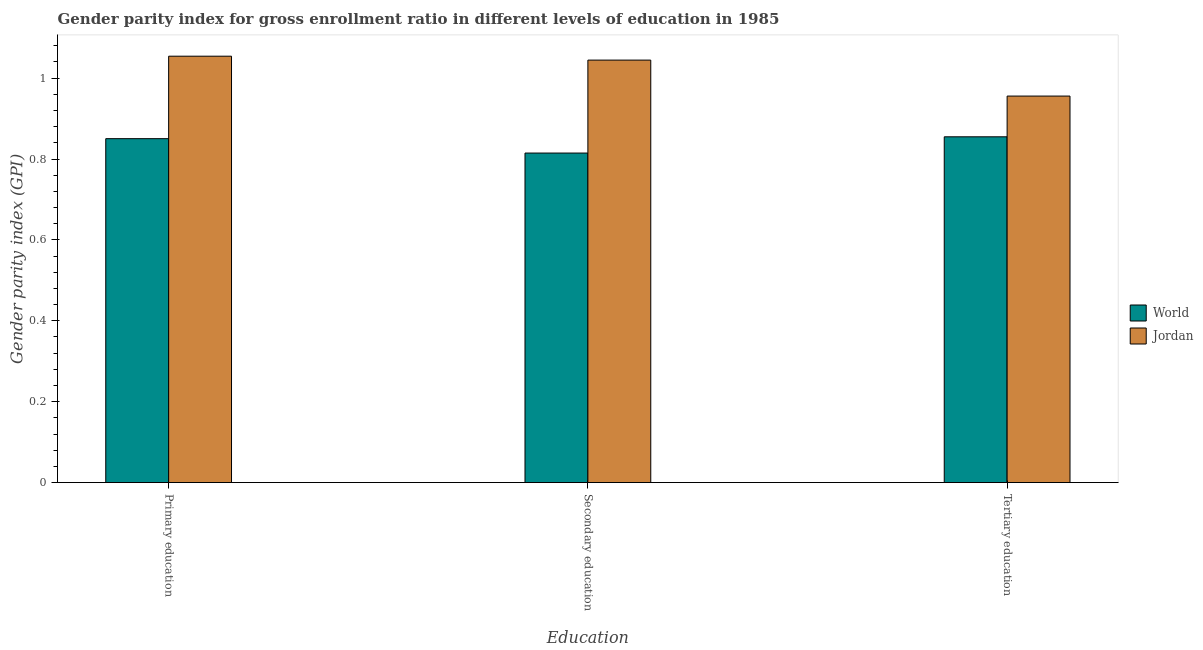How many different coloured bars are there?
Your answer should be compact. 2. How many groups of bars are there?
Offer a terse response. 3. What is the label of the 2nd group of bars from the left?
Provide a short and direct response. Secondary education. What is the gender parity index in secondary education in Jordan?
Provide a succinct answer. 1.04. Across all countries, what is the maximum gender parity index in primary education?
Provide a succinct answer. 1.05. Across all countries, what is the minimum gender parity index in tertiary education?
Provide a short and direct response. 0.85. In which country was the gender parity index in primary education maximum?
Ensure brevity in your answer.  Jordan. What is the total gender parity index in secondary education in the graph?
Keep it short and to the point. 1.86. What is the difference between the gender parity index in secondary education in Jordan and that in World?
Offer a very short reply. 0.23. What is the difference between the gender parity index in tertiary education in Jordan and the gender parity index in primary education in World?
Offer a very short reply. 0.11. What is the average gender parity index in tertiary education per country?
Give a very brief answer. 0.91. What is the difference between the gender parity index in secondary education and gender parity index in tertiary education in World?
Your response must be concise. -0.04. What is the ratio of the gender parity index in secondary education in World to that in Jordan?
Your response must be concise. 0.78. What is the difference between the highest and the second highest gender parity index in primary education?
Provide a succinct answer. 0.2. What is the difference between the highest and the lowest gender parity index in secondary education?
Make the answer very short. 0.23. In how many countries, is the gender parity index in primary education greater than the average gender parity index in primary education taken over all countries?
Keep it short and to the point. 1. Is the sum of the gender parity index in tertiary education in World and Jordan greater than the maximum gender parity index in secondary education across all countries?
Offer a very short reply. Yes. What does the 1st bar from the left in Primary education represents?
Give a very brief answer. World. What does the 2nd bar from the right in Tertiary education represents?
Make the answer very short. World. How many bars are there?
Your response must be concise. 6. What is the difference between two consecutive major ticks on the Y-axis?
Keep it short and to the point. 0.2. Where does the legend appear in the graph?
Make the answer very short. Center right. How many legend labels are there?
Provide a short and direct response. 2. How are the legend labels stacked?
Make the answer very short. Vertical. What is the title of the graph?
Offer a terse response. Gender parity index for gross enrollment ratio in different levels of education in 1985. Does "Pacific island small states" appear as one of the legend labels in the graph?
Ensure brevity in your answer.  No. What is the label or title of the X-axis?
Offer a terse response. Education. What is the label or title of the Y-axis?
Your answer should be very brief. Gender parity index (GPI). What is the Gender parity index (GPI) in World in Primary education?
Keep it short and to the point. 0.85. What is the Gender parity index (GPI) in Jordan in Primary education?
Offer a terse response. 1.05. What is the Gender parity index (GPI) in World in Secondary education?
Your answer should be very brief. 0.81. What is the Gender parity index (GPI) of Jordan in Secondary education?
Provide a short and direct response. 1.04. What is the Gender parity index (GPI) in World in Tertiary education?
Ensure brevity in your answer.  0.85. What is the Gender parity index (GPI) in Jordan in Tertiary education?
Give a very brief answer. 0.96. Across all Education, what is the maximum Gender parity index (GPI) in World?
Make the answer very short. 0.85. Across all Education, what is the maximum Gender parity index (GPI) of Jordan?
Your answer should be very brief. 1.05. Across all Education, what is the minimum Gender parity index (GPI) in World?
Your answer should be compact. 0.81. Across all Education, what is the minimum Gender parity index (GPI) in Jordan?
Ensure brevity in your answer.  0.96. What is the total Gender parity index (GPI) in World in the graph?
Your answer should be compact. 2.52. What is the total Gender parity index (GPI) in Jordan in the graph?
Ensure brevity in your answer.  3.05. What is the difference between the Gender parity index (GPI) of World in Primary education and that in Secondary education?
Offer a terse response. 0.04. What is the difference between the Gender parity index (GPI) in Jordan in Primary education and that in Secondary education?
Offer a terse response. 0.01. What is the difference between the Gender parity index (GPI) of World in Primary education and that in Tertiary education?
Give a very brief answer. -0. What is the difference between the Gender parity index (GPI) of Jordan in Primary education and that in Tertiary education?
Ensure brevity in your answer.  0.1. What is the difference between the Gender parity index (GPI) in World in Secondary education and that in Tertiary education?
Provide a short and direct response. -0.04. What is the difference between the Gender parity index (GPI) in Jordan in Secondary education and that in Tertiary education?
Your answer should be very brief. 0.09. What is the difference between the Gender parity index (GPI) of World in Primary education and the Gender parity index (GPI) of Jordan in Secondary education?
Offer a terse response. -0.19. What is the difference between the Gender parity index (GPI) of World in Primary education and the Gender parity index (GPI) of Jordan in Tertiary education?
Make the answer very short. -0.11. What is the difference between the Gender parity index (GPI) in World in Secondary education and the Gender parity index (GPI) in Jordan in Tertiary education?
Provide a succinct answer. -0.14. What is the average Gender parity index (GPI) of World per Education?
Offer a very short reply. 0.84. What is the average Gender parity index (GPI) in Jordan per Education?
Your answer should be compact. 1.02. What is the difference between the Gender parity index (GPI) in World and Gender parity index (GPI) in Jordan in Primary education?
Offer a very short reply. -0.2. What is the difference between the Gender parity index (GPI) of World and Gender parity index (GPI) of Jordan in Secondary education?
Your answer should be compact. -0.23. What is the difference between the Gender parity index (GPI) of World and Gender parity index (GPI) of Jordan in Tertiary education?
Your response must be concise. -0.1. What is the ratio of the Gender parity index (GPI) in World in Primary education to that in Secondary education?
Provide a short and direct response. 1.04. What is the ratio of the Gender parity index (GPI) of Jordan in Primary education to that in Secondary education?
Offer a very short reply. 1.01. What is the ratio of the Gender parity index (GPI) of World in Primary education to that in Tertiary education?
Provide a succinct answer. 0.99. What is the ratio of the Gender parity index (GPI) of Jordan in Primary education to that in Tertiary education?
Provide a short and direct response. 1.1. What is the ratio of the Gender parity index (GPI) of World in Secondary education to that in Tertiary education?
Your response must be concise. 0.95. What is the ratio of the Gender parity index (GPI) of Jordan in Secondary education to that in Tertiary education?
Offer a terse response. 1.09. What is the difference between the highest and the second highest Gender parity index (GPI) in World?
Your response must be concise. 0. What is the difference between the highest and the second highest Gender parity index (GPI) in Jordan?
Your response must be concise. 0.01. What is the difference between the highest and the lowest Gender parity index (GPI) in World?
Provide a succinct answer. 0.04. What is the difference between the highest and the lowest Gender parity index (GPI) in Jordan?
Offer a terse response. 0.1. 